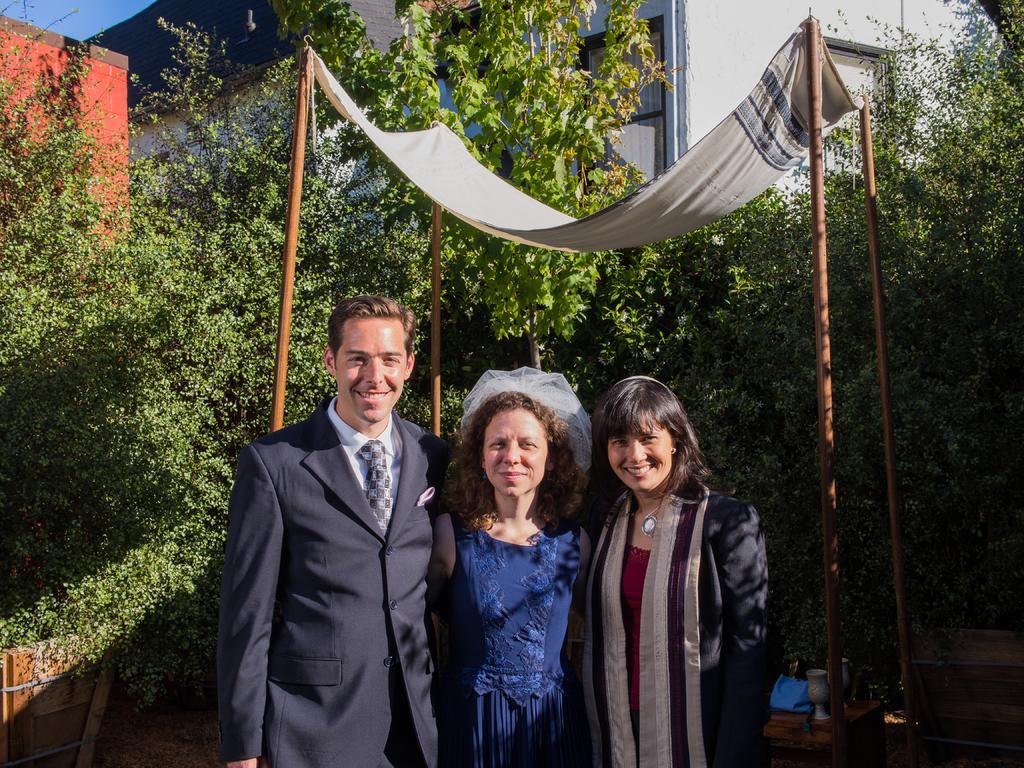How would you summarize this image in a sentence or two? In this image we can see three persons. behind them there are four sticks holding a cloth, and there are two vases, we can see some trees and buildings. 